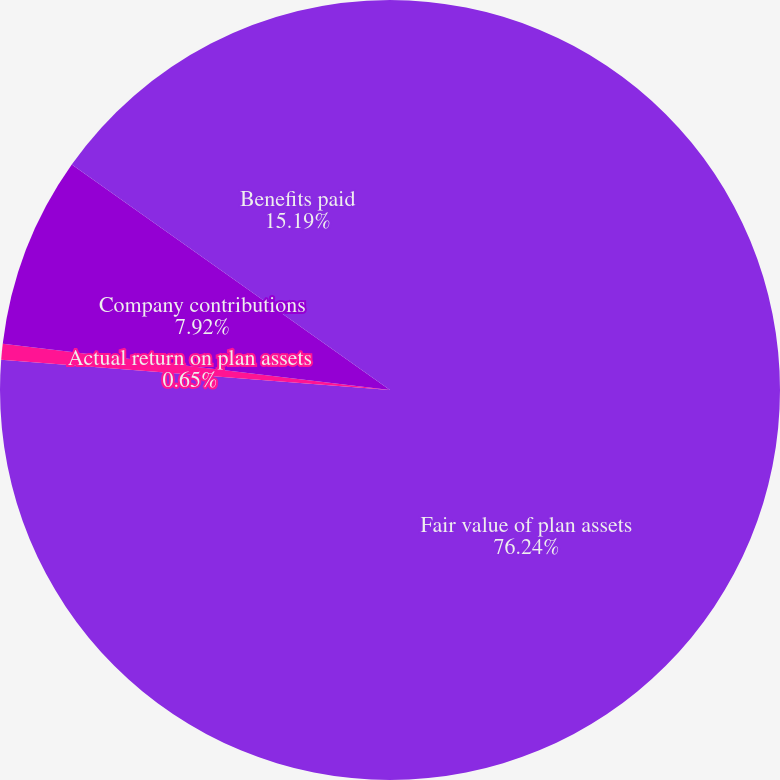Convert chart to OTSL. <chart><loc_0><loc_0><loc_500><loc_500><pie_chart><fcel>Fair value of plan assets<fcel>Actual return on plan assets<fcel>Company contributions<fcel>Benefits paid<nl><fcel>76.24%<fcel>0.65%<fcel>7.92%<fcel>15.19%<nl></chart> 